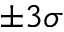<formula> <loc_0><loc_0><loc_500><loc_500>\pm 3 \sigma</formula> 